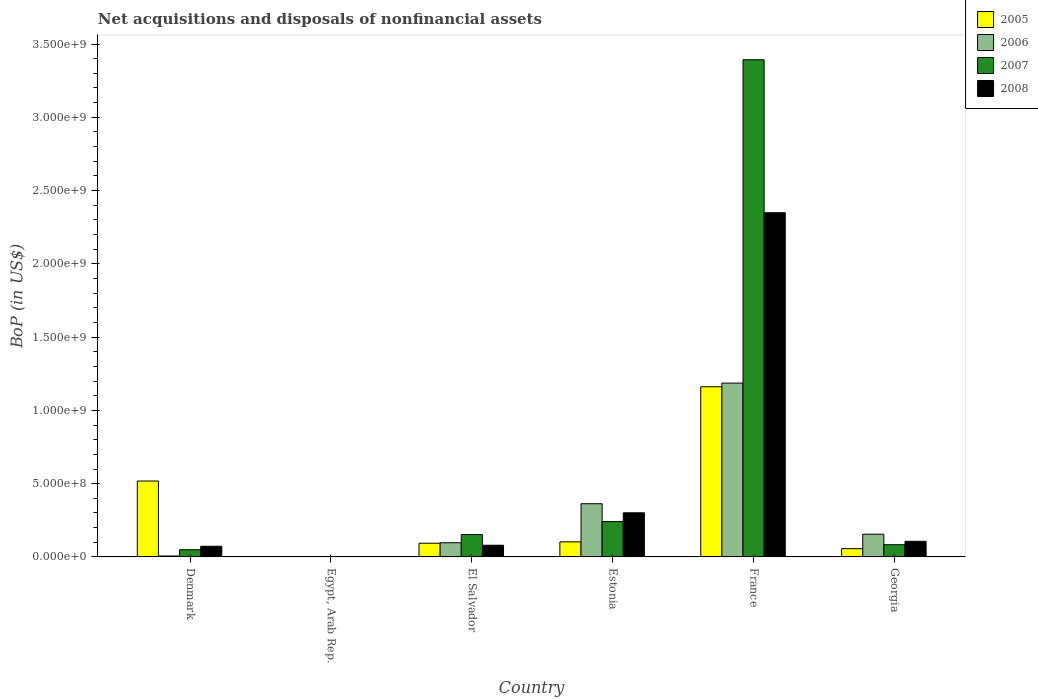How many different coloured bars are there?
Provide a short and direct response. 4. Are the number of bars per tick equal to the number of legend labels?
Offer a terse response. No. Are the number of bars on each tick of the X-axis equal?
Offer a very short reply. No. How many bars are there on the 3rd tick from the left?
Offer a very short reply. 4. In how many cases, is the number of bars for a given country not equal to the number of legend labels?
Keep it short and to the point. 1. What is the Balance of Payments in 2007 in Denmark?
Offer a terse response. 4.93e+07. Across all countries, what is the maximum Balance of Payments in 2008?
Provide a short and direct response. 2.35e+09. Across all countries, what is the minimum Balance of Payments in 2006?
Your answer should be compact. 0. What is the total Balance of Payments in 2008 in the graph?
Make the answer very short. 2.91e+09. What is the difference between the Balance of Payments in 2005 in El Salvador and that in Georgia?
Keep it short and to the point. 3.71e+07. What is the difference between the Balance of Payments in 2005 in Egypt, Arab Rep. and the Balance of Payments in 2007 in El Salvador?
Offer a terse response. -1.53e+08. What is the average Balance of Payments in 2007 per country?
Provide a succinct answer. 6.54e+08. What is the difference between the Balance of Payments of/in 2007 and Balance of Payments of/in 2005 in El Salvador?
Keep it short and to the point. 5.92e+07. What is the ratio of the Balance of Payments in 2007 in El Salvador to that in Georgia?
Ensure brevity in your answer.  1.83. Is the Balance of Payments in 2006 in Denmark less than that in Georgia?
Ensure brevity in your answer.  Yes. What is the difference between the highest and the second highest Balance of Payments in 2005?
Your response must be concise. -6.43e+08. What is the difference between the highest and the lowest Balance of Payments in 2005?
Give a very brief answer. 1.16e+09. Is the sum of the Balance of Payments in 2008 in Denmark and El Salvador greater than the maximum Balance of Payments in 2005 across all countries?
Your response must be concise. No. Is it the case that in every country, the sum of the Balance of Payments in 2007 and Balance of Payments in 2005 is greater than the sum of Balance of Payments in 2008 and Balance of Payments in 2006?
Your answer should be compact. No. How many bars are there?
Offer a very short reply. 21. Are all the bars in the graph horizontal?
Offer a terse response. No. Are the values on the major ticks of Y-axis written in scientific E-notation?
Make the answer very short. Yes. Does the graph contain grids?
Keep it short and to the point. No. What is the title of the graph?
Give a very brief answer. Net acquisitions and disposals of nonfinancial assets. Does "1996" appear as one of the legend labels in the graph?
Your answer should be very brief. No. What is the label or title of the Y-axis?
Give a very brief answer. BoP (in US$). What is the BoP (in US$) of 2005 in Denmark?
Your answer should be compact. 5.18e+08. What is the BoP (in US$) of 2006 in Denmark?
Make the answer very short. 6.28e+06. What is the BoP (in US$) of 2007 in Denmark?
Offer a terse response. 4.93e+07. What is the BoP (in US$) of 2008 in Denmark?
Offer a terse response. 7.29e+07. What is the BoP (in US$) of 2006 in Egypt, Arab Rep.?
Offer a very short reply. 0. What is the BoP (in US$) of 2007 in Egypt, Arab Rep.?
Provide a short and direct response. 1.90e+06. What is the BoP (in US$) in 2008 in Egypt, Arab Rep.?
Make the answer very short. 0. What is the BoP (in US$) in 2005 in El Salvador?
Offer a terse response. 9.36e+07. What is the BoP (in US$) in 2006 in El Salvador?
Offer a very short reply. 9.68e+07. What is the BoP (in US$) in 2007 in El Salvador?
Your response must be concise. 1.53e+08. What is the BoP (in US$) in 2008 in El Salvador?
Provide a short and direct response. 7.98e+07. What is the BoP (in US$) of 2005 in Estonia?
Give a very brief answer. 1.03e+08. What is the BoP (in US$) in 2006 in Estonia?
Your answer should be very brief. 3.63e+08. What is the BoP (in US$) of 2007 in Estonia?
Ensure brevity in your answer.  2.41e+08. What is the BoP (in US$) of 2008 in Estonia?
Keep it short and to the point. 3.01e+08. What is the BoP (in US$) in 2005 in France?
Keep it short and to the point. 1.16e+09. What is the BoP (in US$) of 2006 in France?
Make the answer very short. 1.19e+09. What is the BoP (in US$) of 2007 in France?
Your answer should be compact. 3.39e+09. What is the BoP (in US$) of 2008 in France?
Ensure brevity in your answer.  2.35e+09. What is the BoP (in US$) in 2005 in Georgia?
Provide a short and direct response. 5.65e+07. What is the BoP (in US$) of 2006 in Georgia?
Your answer should be compact. 1.55e+08. What is the BoP (in US$) in 2007 in Georgia?
Make the answer very short. 8.34e+07. What is the BoP (in US$) of 2008 in Georgia?
Keep it short and to the point. 1.07e+08. Across all countries, what is the maximum BoP (in US$) of 2005?
Offer a very short reply. 1.16e+09. Across all countries, what is the maximum BoP (in US$) in 2006?
Your answer should be compact. 1.19e+09. Across all countries, what is the maximum BoP (in US$) in 2007?
Ensure brevity in your answer.  3.39e+09. Across all countries, what is the maximum BoP (in US$) in 2008?
Give a very brief answer. 2.35e+09. Across all countries, what is the minimum BoP (in US$) in 2005?
Give a very brief answer. 0. Across all countries, what is the minimum BoP (in US$) of 2006?
Your response must be concise. 0. Across all countries, what is the minimum BoP (in US$) in 2007?
Offer a very short reply. 1.90e+06. Across all countries, what is the minimum BoP (in US$) in 2008?
Provide a succinct answer. 0. What is the total BoP (in US$) in 2005 in the graph?
Provide a short and direct response. 1.93e+09. What is the total BoP (in US$) of 2006 in the graph?
Ensure brevity in your answer.  1.81e+09. What is the total BoP (in US$) in 2007 in the graph?
Ensure brevity in your answer.  3.92e+09. What is the total BoP (in US$) in 2008 in the graph?
Keep it short and to the point. 2.91e+09. What is the difference between the BoP (in US$) in 2007 in Denmark and that in Egypt, Arab Rep.?
Make the answer very short. 4.74e+07. What is the difference between the BoP (in US$) of 2005 in Denmark and that in El Salvador?
Your answer should be compact. 4.24e+08. What is the difference between the BoP (in US$) of 2006 in Denmark and that in El Salvador?
Keep it short and to the point. -9.05e+07. What is the difference between the BoP (in US$) of 2007 in Denmark and that in El Salvador?
Ensure brevity in your answer.  -1.03e+08. What is the difference between the BoP (in US$) of 2008 in Denmark and that in El Salvador?
Make the answer very short. -6.95e+06. What is the difference between the BoP (in US$) of 2005 in Denmark and that in Estonia?
Offer a very short reply. 4.15e+08. What is the difference between the BoP (in US$) in 2006 in Denmark and that in Estonia?
Offer a very short reply. -3.57e+08. What is the difference between the BoP (in US$) in 2007 in Denmark and that in Estonia?
Ensure brevity in your answer.  -1.92e+08. What is the difference between the BoP (in US$) of 2008 in Denmark and that in Estonia?
Ensure brevity in your answer.  -2.28e+08. What is the difference between the BoP (in US$) of 2005 in Denmark and that in France?
Ensure brevity in your answer.  -6.43e+08. What is the difference between the BoP (in US$) in 2006 in Denmark and that in France?
Offer a very short reply. -1.18e+09. What is the difference between the BoP (in US$) of 2007 in Denmark and that in France?
Your answer should be compact. -3.34e+09. What is the difference between the BoP (in US$) of 2008 in Denmark and that in France?
Your answer should be compact. -2.28e+09. What is the difference between the BoP (in US$) of 2005 in Denmark and that in Georgia?
Ensure brevity in your answer.  4.61e+08. What is the difference between the BoP (in US$) in 2006 in Denmark and that in Georgia?
Ensure brevity in your answer.  -1.49e+08. What is the difference between the BoP (in US$) of 2007 in Denmark and that in Georgia?
Provide a succinct answer. -3.41e+07. What is the difference between the BoP (in US$) in 2008 in Denmark and that in Georgia?
Make the answer very short. -3.38e+07. What is the difference between the BoP (in US$) of 2007 in Egypt, Arab Rep. and that in El Salvador?
Provide a short and direct response. -1.51e+08. What is the difference between the BoP (in US$) of 2007 in Egypt, Arab Rep. and that in Estonia?
Ensure brevity in your answer.  -2.39e+08. What is the difference between the BoP (in US$) of 2007 in Egypt, Arab Rep. and that in France?
Your answer should be very brief. -3.39e+09. What is the difference between the BoP (in US$) in 2007 in Egypt, Arab Rep. and that in Georgia?
Keep it short and to the point. -8.15e+07. What is the difference between the BoP (in US$) in 2005 in El Salvador and that in Estonia?
Make the answer very short. -9.37e+06. What is the difference between the BoP (in US$) of 2006 in El Salvador and that in Estonia?
Ensure brevity in your answer.  -2.66e+08. What is the difference between the BoP (in US$) in 2007 in El Salvador and that in Estonia?
Offer a very short reply. -8.84e+07. What is the difference between the BoP (in US$) of 2008 in El Salvador and that in Estonia?
Make the answer very short. -2.21e+08. What is the difference between the BoP (in US$) in 2005 in El Salvador and that in France?
Ensure brevity in your answer.  -1.07e+09. What is the difference between the BoP (in US$) in 2006 in El Salvador and that in France?
Your answer should be very brief. -1.09e+09. What is the difference between the BoP (in US$) of 2007 in El Salvador and that in France?
Provide a short and direct response. -3.24e+09. What is the difference between the BoP (in US$) of 2008 in El Salvador and that in France?
Your response must be concise. -2.27e+09. What is the difference between the BoP (in US$) in 2005 in El Salvador and that in Georgia?
Keep it short and to the point. 3.71e+07. What is the difference between the BoP (in US$) of 2006 in El Salvador and that in Georgia?
Your response must be concise. -5.83e+07. What is the difference between the BoP (in US$) in 2007 in El Salvador and that in Georgia?
Offer a terse response. 6.94e+07. What is the difference between the BoP (in US$) of 2008 in El Salvador and that in Georgia?
Provide a short and direct response. -2.68e+07. What is the difference between the BoP (in US$) in 2005 in Estonia and that in France?
Your response must be concise. -1.06e+09. What is the difference between the BoP (in US$) of 2006 in Estonia and that in France?
Make the answer very short. -8.23e+08. What is the difference between the BoP (in US$) in 2007 in Estonia and that in France?
Your answer should be compact. -3.15e+09. What is the difference between the BoP (in US$) of 2008 in Estonia and that in France?
Make the answer very short. -2.05e+09. What is the difference between the BoP (in US$) in 2005 in Estonia and that in Georgia?
Offer a very short reply. 4.65e+07. What is the difference between the BoP (in US$) of 2006 in Estonia and that in Georgia?
Provide a short and direct response. 2.08e+08. What is the difference between the BoP (in US$) in 2007 in Estonia and that in Georgia?
Ensure brevity in your answer.  1.58e+08. What is the difference between the BoP (in US$) in 2008 in Estonia and that in Georgia?
Ensure brevity in your answer.  1.94e+08. What is the difference between the BoP (in US$) in 2005 in France and that in Georgia?
Provide a succinct answer. 1.10e+09. What is the difference between the BoP (in US$) of 2006 in France and that in Georgia?
Your answer should be very brief. 1.03e+09. What is the difference between the BoP (in US$) in 2007 in France and that in Georgia?
Keep it short and to the point. 3.31e+09. What is the difference between the BoP (in US$) in 2008 in France and that in Georgia?
Provide a succinct answer. 2.24e+09. What is the difference between the BoP (in US$) of 2005 in Denmark and the BoP (in US$) of 2007 in Egypt, Arab Rep.?
Offer a very short reply. 5.16e+08. What is the difference between the BoP (in US$) of 2006 in Denmark and the BoP (in US$) of 2007 in Egypt, Arab Rep.?
Provide a succinct answer. 4.38e+06. What is the difference between the BoP (in US$) of 2005 in Denmark and the BoP (in US$) of 2006 in El Salvador?
Keep it short and to the point. 4.21e+08. What is the difference between the BoP (in US$) in 2005 in Denmark and the BoP (in US$) in 2007 in El Salvador?
Make the answer very short. 3.65e+08. What is the difference between the BoP (in US$) of 2005 in Denmark and the BoP (in US$) of 2008 in El Salvador?
Provide a succinct answer. 4.38e+08. What is the difference between the BoP (in US$) of 2006 in Denmark and the BoP (in US$) of 2007 in El Salvador?
Offer a terse response. -1.47e+08. What is the difference between the BoP (in US$) of 2006 in Denmark and the BoP (in US$) of 2008 in El Salvador?
Your answer should be compact. -7.35e+07. What is the difference between the BoP (in US$) in 2007 in Denmark and the BoP (in US$) in 2008 in El Salvador?
Your answer should be compact. -3.05e+07. What is the difference between the BoP (in US$) of 2005 in Denmark and the BoP (in US$) of 2006 in Estonia?
Provide a short and direct response. 1.55e+08. What is the difference between the BoP (in US$) of 2005 in Denmark and the BoP (in US$) of 2007 in Estonia?
Make the answer very short. 2.77e+08. What is the difference between the BoP (in US$) of 2005 in Denmark and the BoP (in US$) of 2008 in Estonia?
Your answer should be very brief. 2.17e+08. What is the difference between the BoP (in US$) of 2006 in Denmark and the BoP (in US$) of 2007 in Estonia?
Your response must be concise. -2.35e+08. What is the difference between the BoP (in US$) in 2006 in Denmark and the BoP (in US$) in 2008 in Estonia?
Your answer should be compact. -2.95e+08. What is the difference between the BoP (in US$) of 2007 in Denmark and the BoP (in US$) of 2008 in Estonia?
Offer a terse response. -2.52e+08. What is the difference between the BoP (in US$) in 2005 in Denmark and the BoP (in US$) in 2006 in France?
Ensure brevity in your answer.  -6.68e+08. What is the difference between the BoP (in US$) in 2005 in Denmark and the BoP (in US$) in 2007 in France?
Your answer should be compact. -2.87e+09. What is the difference between the BoP (in US$) in 2005 in Denmark and the BoP (in US$) in 2008 in France?
Give a very brief answer. -1.83e+09. What is the difference between the BoP (in US$) in 2006 in Denmark and the BoP (in US$) in 2007 in France?
Your answer should be compact. -3.39e+09. What is the difference between the BoP (in US$) of 2006 in Denmark and the BoP (in US$) of 2008 in France?
Your answer should be very brief. -2.34e+09. What is the difference between the BoP (in US$) of 2007 in Denmark and the BoP (in US$) of 2008 in France?
Offer a very short reply. -2.30e+09. What is the difference between the BoP (in US$) in 2005 in Denmark and the BoP (in US$) in 2006 in Georgia?
Provide a short and direct response. 3.63e+08. What is the difference between the BoP (in US$) of 2005 in Denmark and the BoP (in US$) of 2007 in Georgia?
Provide a succinct answer. 4.35e+08. What is the difference between the BoP (in US$) in 2005 in Denmark and the BoP (in US$) in 2008 in Georgia?
Make the answer very short. 4.11e+08. What is the difference between the BoP (in US$) in 2006 in Denmark and the BoP (in US$) in 2007 in Georgia?
Your answer should be compact. -7.71e+07. What is the difference between the BoP (in US$) in 2006 in Denmark and the BoP (in US$) in 2008 in Georgia?
Keep it short and to the point. -1.00e+08. What is the difference between the BoP (in US$) of 2007 in Denmark and the BoP (in US$) of 2008 in Georgia?
Provide a succinct answer. -5.73e+07. What is the difference between the BoP (in US$) of 2007 in Egypt, Arab Rep. and the BoP (in US$) of 2008 in El Salvador?
Offer a very short reply. -7.79e+07. What is the difference between the BoP (in US$) in 2007 in Egypt, Arab Rep. and the BoP (in US$) in 2008 in Estonia?
Provide a succinct answer. -2.99e+08. What is the difference between the BoP (in US$) in 2007 in Egypt, Arab Rep. and the BoP (in US$) in 2008 in France?
Provide a short and direct response. -2.35e+09. What is the difference between the BoP (in US$) in 2007 in Egypt, Arab Rep. and the BoP (in US$) in 2008 in Georgia?
Your response must be concise. -1.05e+08. What is the difference between the BoP (in US$) of 2005 in El Salvador and the BoP (in US$) of 2006 in Estonia?
Provide a short and direct response. -2.69e+08. What is the difference between the BoP (in US$) of 2005 in El Salvador and the BoP (in US$) of 2007 in Estonia?
Make the answer very short. -1.48e+08. What is the difference between the BoP (in US$) in 2005 in El Salvador and the BoP (in US$) in 2008 in Estonia?
Ensure brevity in your answer.  -2.07e+08. What is the difference between the BoP (in US$) of 2006 in El Salvador and the BoP (in US$) of 2007 in Estonia?
Offer a terse response. -1.44e+08. What is the difference between the BoP (in US$) of 2006 in El Salvador and the BoP (in US$) of 2008 in Estonia?
Offer a very short reply. -2.04e+08. What is the difference between the BoP (in US$) of 2007 in El Salvador and the BoP (in US$) of 2008 in Estonia?
Give a very brief answer. -1.48e+08. What is the difference between the BoP (in US$) in 2005 in El Salvador and the BoP (in US$) in 2006 in France?
Your answer should be compact. -1.09e+09. What is the difference between the BoP (in US$) in 2005 in El Salvador and the BoP (in US$) in 2007 in France?
Offer a terse response. -3.30e+09. What is the difference between the BoP (in US$) in 2005 in El Salvador and the BoP (in US$) in 2008 in France?
Provide a succinct answer. -2.26e+09. What is the difference between the BoP (in US$) of 2006 in El Salvador and the BoP (in US$) of 2007 in France?
Your answer should be very brief. -3.30e+09. What is the difference between the BoP (in US$) in 2006 in El Salvador and the BoP (in US$) in 2008 in France?
Make the answer very short. -2.25e+09. What is the difference between the BoP (in US$) in 2007 in El Salvador and the BoP (in US$) in 2008 in France?
Give a very brief answer. -2.20e+09. What is the difference between the BoP (in US$) of 2005 in El Salvador and the BoP (in US$) of 2006 in Georgia?
Offer a terse response. -6.15e+07. What is the difference between the BoP (in US$) of 2005 in El Salvador and the BoP (in US$) of 2007 in Georgia?
Ensure brevity in your answer.  1.02e+07. What is the difference between the BoP (in US$) of 2005 in El Salvador and the BoP (in US$) of 2008 in Georgia?
Keep it short and to the point. -1.30e+07. What is the difference between the BoP (in US$) in 2006 in El Salvador and the BoP (in US$) in 2007 in Georgia?
Your response must be concise. 1.34e+07. What is the difference between the BoP (in US$) of 2006 in El Salvador and the BoP (in US$) of 2008 in Georgia?
Give a very brief answer. -9.82e+06. What is the difference between the BoP (in US$) of 2007 in El Salvador and the BoP (in US$) of 2008 in Georgia?
Your answer should be very brief. 4.62e+07. What is the difference between the BoP (in US$) in 2005 in Estonia and the BoP (in US$) in 2006 in France?
Offer a very short reply. -1.08e+09. What is the difference between the BoP (in US$) of 2005 in Estonia and the BoP (in US$) of 2007 in France?
Provide a succinct answer. -3.29e+09. What is the difference between the BoP (in US$) of 2005 in Estonia and the BoP (in US$) of 2008 in France?
Offer a terse response. -2.25e+09. What is the difference between the BoP (in US$) of 2006 in Estonia and the BoP (in US$) of 2007 in France?
Your answer should be compact. -3.03e+09. What is the difference between the BoP (in US$) in 2006 in Estonia and the BoP (in US$) in 2008 in France?
Your answer should be very brief. -1.99e+09. What is the difference between the BoP (in US$) of 2007 in Estonia and the BoP (in US$) of 2008 in France?
Offer a terse response. -2.11e+09. What is the difference between the BoP (in US$) of 2005 in Estonia and the BoP (in US$) of 2006 in Georgia?
Keep it short and to the point. -5.21e+07. What is the difference between the BoP (in US$) in 2005 in Estonia and the BoP (in US$) in 2007 in Georgia?
Ensure brevity in your answer.  1.96e+07. What is the difference between the BoP (in US$) in 2005 in Estonia and the BoP (in US$) in 2008 in Georgia?
Offer a terse response. -3.65e+06. What is the difference between the BoP (in US$) in 2006 in Estonia and the BoP (in US$) in 2007 in Georgia?
Provide a short and direct response. 2.80e+08. What is the difference between the BoP (in US$) of 2006 in Estonia and the BoP (in US$) of 2008 in Georgia?
Your answer should be compact. 2.56e+08. What is the difference between the BoP (in US$) of 2007 in Estonia and the BoP (in US$) of 2008 in Georgia?
Ensure brevity in your answer.  1.35e+08. What is the difference between the BoP (in US$) of 2005 in France and the BoP (in US$) of 2006 in Georgia?
Your answer should be very brief. 1.01e+09. What is the difference between the BoP (in US$) of 2005 in France and the BoP (in US$) of 2007 in Georgia?
Your response must be concise. 1.08e+09. What is the difference between the BoP (in US$) of 2005 in France and the BoP (in US$) of 2008 in Georgia?
Offer a terse response. 1.05e+09. What is the difference between the BoP (in US$) in 2006 in France and the BoP (in US$) in 2007 in Georgia?
Give a very brief answer. 1.10e+09. What is the difference between the BoP (in US$) of 2006 in France and the BoP (in US$) of 2008 in Georgia?
Make the answer very short. 1.08e+09. What is the difference between the BoP (in US$) of 2007 in France and the BoP (in US$) of 2008 in Georgia?
Offer a very short reply. 3.29e+09. What is the average BoP (in US$) in 2005 per country?
Ensure brevity in your answer.  3.22e+08. What is the average BoP (in US$) of 2006 per country?
Your answer should be compact. 3.01e+08. What is the average BoP (in US$) in 2007 per country?
Give a very brief answer. 6.54e+08. What is the average BoP (in US$) of 2008 per country?
Your answer should be compact. 4.85e+08. What is the difference between the BoP (in US$) of 2005 and BoP (in US$) of 2006 in Denmark?
Offer a terse response. 5.12e+08. What is the difference between the BoP (in US$) in 2005 and BoP (in US$) in 2007 in Denmark?
Provide a short and direct response. 4.69e+08. What is the difference between the BoP (in US$) of 2005 and BoP (in US$) of 2008 in Denmark?
Provide a succinct answer. 4.45e+08. What is the difference between the BoP (in US$) in 2006 and BoP (in US$) in 2007 in Denmark?
Offer a very short reply. -4.30e+07. What is the difference between the BoP (in US$) of 2006 and BoP (in US$) of 2008 in Denmark?
Offer a very short reply. -6.66e+07. What is the difference between the BoP (in US$) in 2007 and BoP (in US$) in 2008 in Denmark?
Make the answer very short. -2.35e+07. What is the difference between the BoP (in US$) in 2005 and BoP (in US$) in 2006 in El Salvador?
Provide a short and direct response. -3.20e+06. What is the difference between the BoP (in US$) of 2005 and BoP (in US$) of 2007 in El Salvador?
Offer a very short reply. -5.92e+07. What is the difference between the BoP (in US$) of 2005 and BoP (in US$) of 2008 in El Salvador?
Your response must be concise. 1.38e+07. What is the difference between the BoP (in US$) of 2006 and BoP (in US$) of 2007 in El Salvador?
Make the answer very short. -5.60e+07. What is the difference between the BoP (in US$) in 2006 and BoP (in US$) in 2008 in El Salvador?
Keep it short and to the point. 1.70e+07. What is the difference between the BoP (in US$) of 2007 and BoP (in US$) of 2008 in El Salvador?
Give a very brief answer. 7.30e+07. What is the difference between the BoP (in US$) in 2005 and BoP (in US$) in 2006 in Estonia?
Provide a succinct answer. -2.60e+08. What is the difference between the BoP (in US$) in 2005 and BoP (in US$) in 2007 in Estonia?
Provide a succinct answer. -1.38e+08. What is the difference between the BoP (in US$) of 2005 and BoP (in US$) of 2008 in Estonia?
Provide a short and direct response. -1.98e+08. What is the difference between the BoP (in US$) of 2006 and BoP (in US$) of 2007 in Estonia?
Provide a short and direct response. 1.22e+08. What is the difference between the BoP (in US$) of 2006 and BoP (in US$) of 2008 in Estonia?
Offer a terse response. 6.19e+07. What is the difference between the BoP (in US$) of 2007 and BoP (in US$) of 2008 in Estonia?
Ensure brevity in your answer.  -5.99e+07. What is the difference between the BoP (in US$) in 2005 and BoP (in US$) in 2006 in France?
Your answer should be compact. -2.51e+07. What is the difference between the BoP (in US$) of 2005 and BoP (in US$) of 2007 in France?
Ensure brevity in your answer.  -2.23e+09. What is the difference between the BoP (in US$) of 2005 and BoP (in US$) of 2008 in France?
Make the answer very short. -1.19e+09. What is the difference between the BoP (in US$) in 2006 and BoP (in US$) in 2007 in France?
Provide a short and direct response. -2.21e+09. What is the difference between the BoP (in US$) in 2006 and BoP (in US$) in 2008 in France?
Offer a terse response. -1.16e+09. What is the difference between the BoP (in US$) of 2007 and BoP (in US$) of 2008 in France?
Keep it short and to the point. 1.04e+09. What is the difference between the BoP (in US$) of 2005 and BoP (in US$) of 2006 in Georgia?
Keep it short and to the point. -9.86e+07. What is the difference between the BoP (in US$) of 2005 and BoP (in US$) of 2007 in Georgia?
Ensure brevity in your answer.  -2.69e+07. What is the difference between the BoP (in US$) of 2005 and BoP (in US$) of 2008 in Georgia?
Offer a very short reply. -5.01e+07. What is the difference between the BoP (in US$) of 2006 and BoP (in US$) of 2007 in Georgia?
Your answer should be compact. 7.17e+07. What is the difference between the BoP (in US$) of 2006 and BoP (in US$) of 2008 in Georgia?
Your answer should be very brief. 4.85e+07. What is the difference between the BoP (in US$) of 2007 and BoP (in US$) of 2008 in Georgia?
Your answer should be compact. -2.32e+07. What is the ratio of the BoP (in US$) of 2007 in Denmark to that in Egypt, Arab Rep.?
Provide a short and direct response. 25.95. What is the ratio of the BoP (in US$) in 2005 in Denmark to that in El Salvador?
Make the answer very short. 5.53. What is the ratio of the BoP (in US$) of 2006 in Denmark to that in El Salvador?
Provide a short and direct response. 0.06. What is the ratio of the BoP (in US$) of 2007 in Denmark to that in El Salvador?
Provide a succinct answer. 0.32. What is the ratio of the BoP (in US$) of 2008 in Denmark to that in El Salvador?
Provide a succinct answer. 0.91. What is the ratio of the BoP (in US$) of 2005 in Denmark to that in Estonia?
Your answer should be compact. 5.03. What is the ratio of the BoP (in US$) of 2006 in Denmark to that in Estonia?
Keep it short and to the point. 0.02. What is the ratio of the BoP (in US$) of 2007 in Denmark to that in Estonia?
Ensure brevity in your answer.  0.2. What is the ratio of the BoP (in US$) of 2008 in Denmark to that in Estonia?
Your answer should be very brief. 0.24. What is the ratio of the BoP (in US$) in 2005 in Denmark to that in France?
Offer a terse response. 0.45. What is the ratio of the BoP (in US$) in 2006 in Denmark to that in France?
Your answer should be compact. 0.01. What is the ratio of the BoP (in US$) in 2007 in Denmark to that in France?
Provide a succinct answer. 0.01. What is the ratio of the BoP (in US$) in 2008 in Denmark to that in France?
Provide a succinct answer. 0.03. What is the ratio of the BoP (in US$) in 2005 in Denmark to that in Georgia?
Give a very brief answer. 9.17. What is the ratio of the BoP (in US$) in 2006 in Denmark to that in Georgia?
Offer a very short reply. 0.04. What is the ratio of the BoP (in US$) in 2007 in Denmark to that in Georgia?
Provide a short and direct response. 0.59. What is the ratio of the BoP (in US$) in 2008 in Denmark to that in Georgia?
Make the answer very short. 0.68. What is the ratio of the BoP (in US$) of 2007 in Egypt, Arab Rep. to that in El Salvador?
Ensure brevity in your answer.  0.01. What is the ratio of the BoP (in US$) in 2007 in Egypt, Arab Rep. to that in Estonia?
Ensure brevity in your answer.  0.01. What is the ratio of the BoP (in US$) of 2007 in Egypt, Arab Rep. to that in France?
Your response must be concise. 0. What is the ratio of the BoP (in US$) in 2007 in Egypt, Arab Rep. to that in Georgia?
Your answer should be compact. 0.02. What is the ratio of the BoP (in US$) in 2005 in El Salvador to that in Estonia?
Give a very brief answer. 0.91. What is the ratio of the BoP (in US$) in 2006 in El Salvador to that in Estonia?
Offer a terse response. 0.27. What is the ratio of the BoP (in US$) in 2007 in El Salvador to that in Estonia?
Your answer should be very brief. 0.63. What is the ratio of the BoP (in US$) of 2008 in El Salvador to that in Estonia?
Your answer should be compact. 0.27. What is the ratio of the BoP (in US$) of 2005 in El Salvador to that in France?
Make the answer very short. 0.08. What is the ratio of the BoP (in US$) in 2006 in El Salvador to that in France?
Your answer should be compact. 0.08. What is the ratio of the BoP (in US$) in 2007 in El Salvador to that in France?
Make the answer very short. 0.04. What is the ratio of the BoP (in US$) in 2008 in El Salvador to that in France?
Your response must be concise. 0.03. What is the ratio of the BoP (in US$) in 2005 in El Salvador to that in Georgia?
Your answer should be compact. 1.66. What is the ratio of the BoP (in US$) of 2006 in El Salvador to that in Georgia?
Provide a short and direct response. 0.62. What is the ratio of the BoP (in US$) in 2007 in El Salvador to that in Georgia?
Provide a short and direct response. 1.83. What is the ratio of the BoP (in US$) in 2008 in El Salvador to that in Georgia?
Make the answer very short. 0.75. What is the ratio of the BoP (in US$) in 2005 in Estonia to that in France?
Offer a terse response. 0.09. What is the ratio of the BoP (in US$) of 2006 in Estonia to that in France?
Keep it short and to the point. 0.31. What is the ratio of the BoP (in US$) of 2007 in Estonia to that in France?
Your answer should be very brief. 0.07. What is the ratio of the BoP (in US$) in 2008 in Estonia to that in France?
Keep it short and to the point. 0.13. What is the ratio of the BoP (in US$) of 2005 in Estonia to that in Georgia?
Your answer should be compact. 1.82. What is the ratio of the BoP (in US$) in 2006 in Estonia to that in Georgia?
Keep it short and to the point. 2.34. What is the ratio of the BoP (in US$) of 2007 in Estonia to that in Georgia?
Your response must be concise. 2.89. What is the ratio of the BoP (in US$) in 2008 in Estonia to that in Georgia?
Offer a terse response. 2.82. What is the ratio of the BoP (in US$) of 2005 in France to that in Georgia?
Keep it short and to the point. 20.56. What is the ratio of the BoP (in US$) in 2006 in France to that in Georgia?
Provide a succinct answer. 7.65. What is the ratio of the BoP (in US$) of 2007 in France to that in Georgia?
Make the answer very short. 40.68. What is the ratio of the BoP (in US$) in 2008 in France to that in Georgia?
Provide a short and direct response. 22.03. What is the difference between the highest and the second highest BoP (in US$) in 2005?
Your answer should be compact. 6.43e+08. What is the difference between the highest and the second highest BoP (in US$) of 2006?
Your answer should be very brief. 8.23e+08. What is the difference between the highest and the second highest BoP (in US$) in 2007?
Offer a terse response. 3.15e+09. What is the difference between the highest and the second highest BoP (in US$) in 2008?
Your answer should be very brief. 2.05e+09. What is the difference between the highest and the lowest BoP (in US$) of 2005?
Offer a very short reply. 1.16e+09. What is the difference between the highest and the lowest BoP (in US$) in 2006?
Offer a very short reply. 1.19e+09. What is the difference between the highest and the lowest BoP (in US$) of 2007?
Offer a terse response. 3.39e+09. What is the difference between the highest and the lowest BoP (in US$) of 2008?
Your answer should be compact. 2.35e+09. 